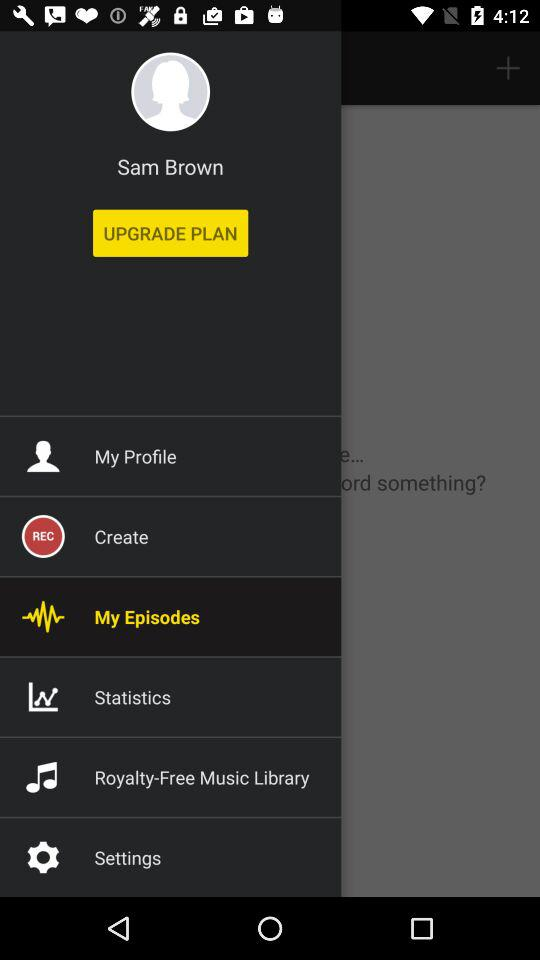Which option is selected? The selected option is My Episodes. 